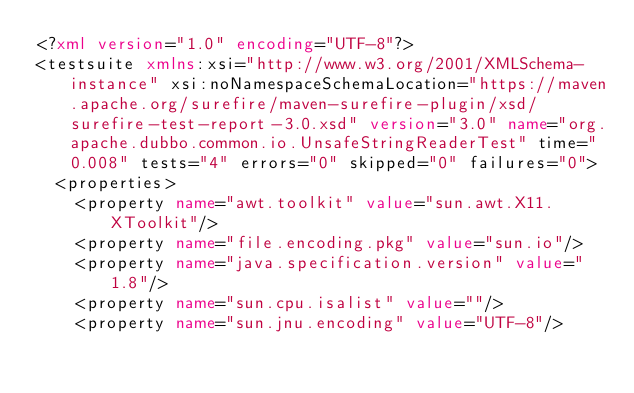Convert code to text. <code><loc_0><loc_0><loc_500><loc_500><_XML_><?xml version="1.0" encoding="UTF-8"?>
<testsuite xmlns:xsi="http://www.w3.org/2001/XMLSchema-instance" xsi:noNamespaceSchemaLocation="https://maven.apache.org/surefire/maven-surefire-plugin/xsd/surefire-test-report-3.0.xsd" version="3.0" name="org.apache.dubbo.common.io.UnsafeStringReaderTest" time="0.008" tests="4" errors="0" skipped="0" failures="0">
  <properties>
    <property name="awt.toolkit" value="sun.awt.X11.XToolkit"/>
    <property name="file.encoding.pkg" value="sun.io"/>
    <property name="java.specification.version" value="1.8"/>
    <property name="sun.cpu.isalist" value=""/>
    <property name="sun.jnu.encoding" value="UTF-8"/></code> 